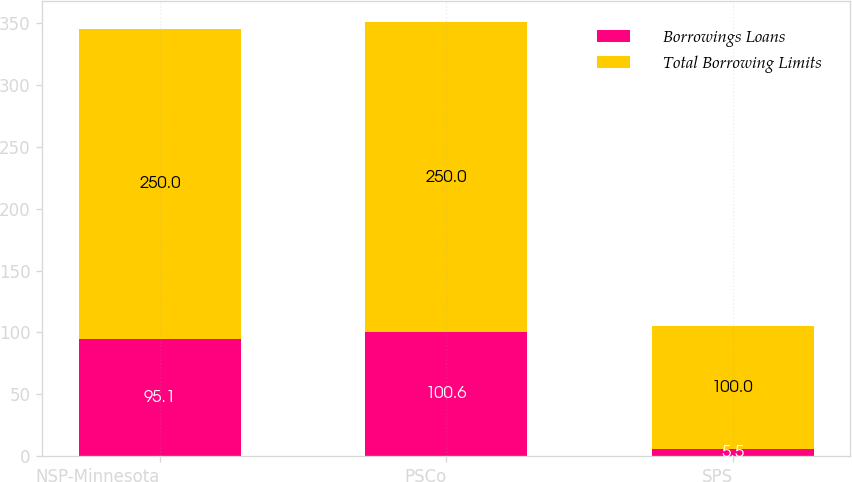<chart> <loc_0><loc_0><loc_500><loc_500><stacked_bar_chart><ecel><fcel>NSP-Minnesota<fcel>PSCo<fcel>SPS<nl><fcel>Borrowings Loans<fcel>95.1<fcel>100.6<fcel>5.5<nl><fcel>Total Borrowing Limits<fcel>250<fcel>250<fcel>100<nl></chart> 